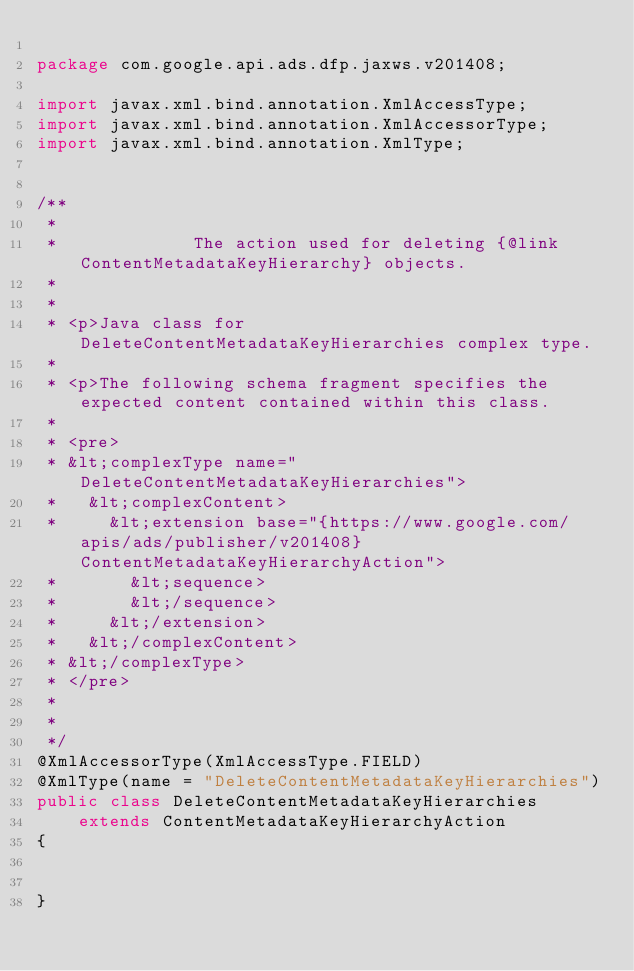<code> <loc_0><loc_0><loc_500><loc_500><_Java_>
package com.google.api.ads.dfp.jaxws.v201408;

import javax.xml.bind.annotation.XmlAccessType;
import javax.xml.bind.annotation.XmlAccessorType;
import javax.xml.bind.annotation.XmlType;


/**
 * 
 *             The action used for deleting {@link ContentMetadataKeyHierarchy} objects.
 *           
 * 
 * <p>Java class for DeleteContentMetadataKeyHierarchies complex type.
 * 
 * <p>The following schema fragment specifies the expected content contained within this class.
 * 
 * <pre>
 * &lt;complexType name="DeleteContentMetadataKeyHierarchies">
 *   &lt;complexContent>
 *     &lt;extension base="{https://www.google.com/apis/ads/publisher/v201408}ContentMetadataKeyHierarchyAction">
 *       &lt;sequence>
 *       &lt;/sequence>
 *     &lt;/extension>
 *   &lt;/complexContent>
 * &lt;/complexType>
 * </pre>
 * 
 * 
 */
@XmlAccessorType(XmlAccessType.FIELD)
@XmlType(name = "DeleteContentMetadataKeyHierarchies")
public class DeleteContentMetadataKeyHierarchies
    extends ContentMetadataKeyHierarchyAction
{


}
</code> 